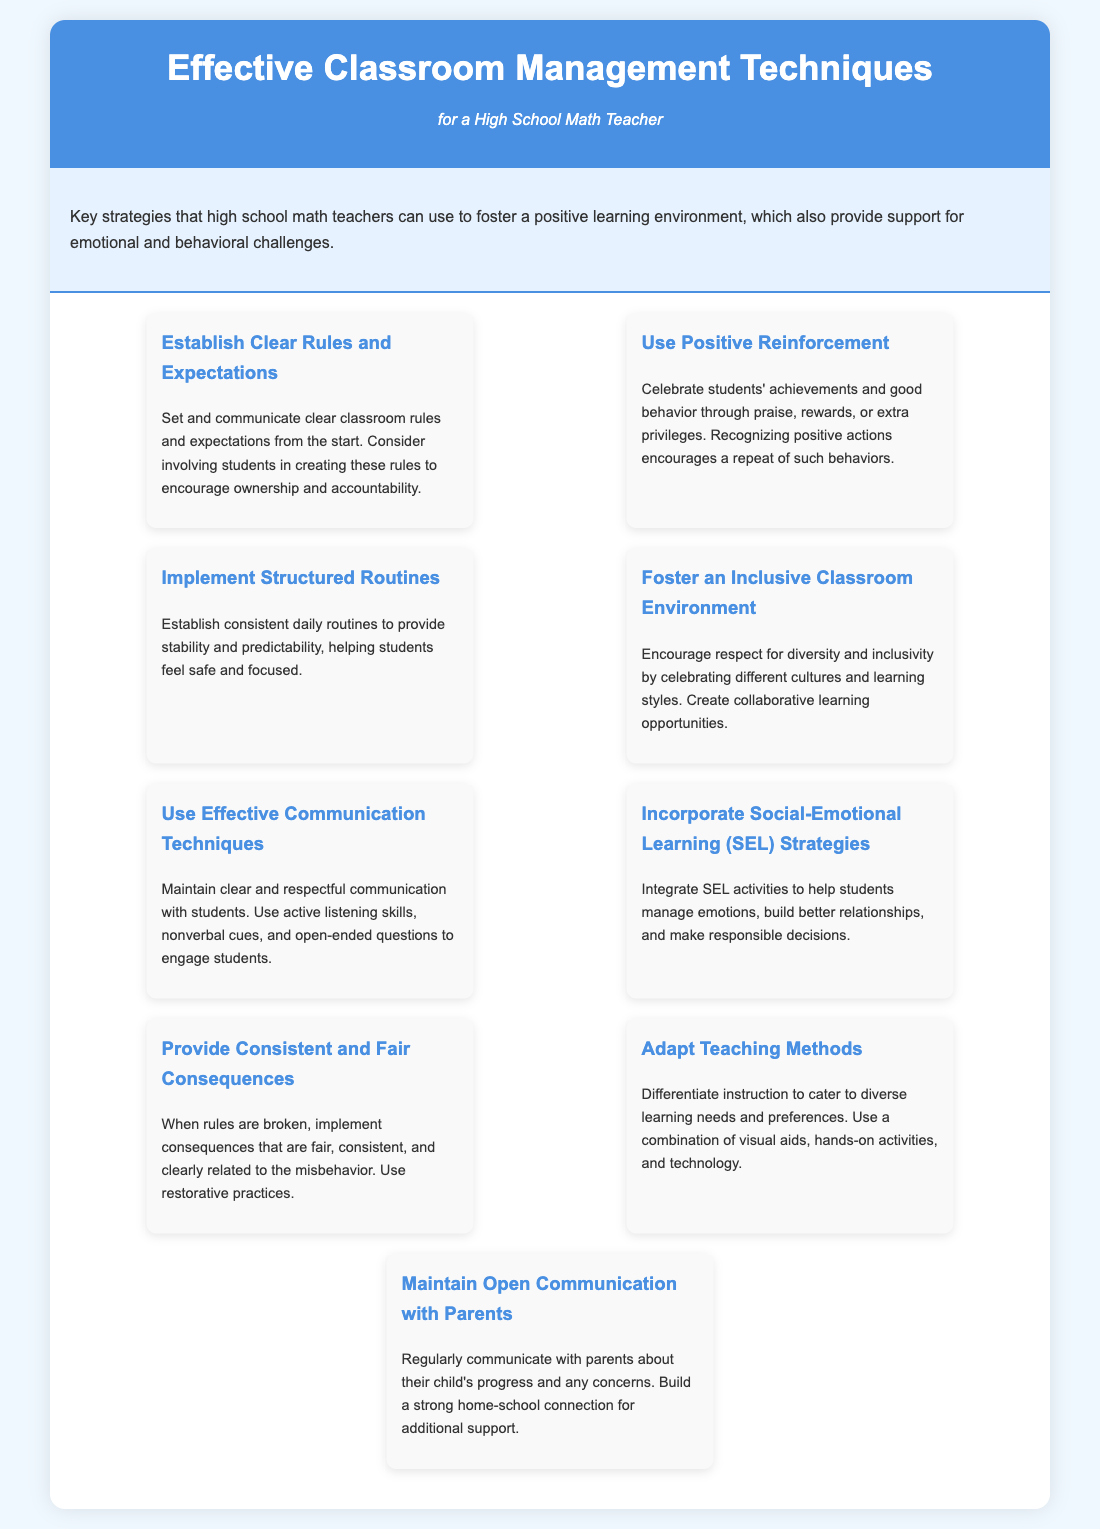What is the title of the infographic? The title is the main heading at the top of the document, summarizing its content.
Answer: Effective Classroom Management Techniques How many techniques are listed? The document contains a specific number of distinct techniques for classroom management, detailed in the infographic.
Answer: Nine What is one technique for creating inclusivity? This question asks for a specific technique mentioned in the document that focuses on inclusivity in the classroom.
Answer: Foster an Inclusive Classroom Environment What strategy should be used for consistent behavior? This question focuses on a specific technique aimed at maintaining consistent behavior among students.
Answer: Provide Consistent and Fair Consequences What type of reinforcement is suggested in the document? This question asks about the approach taken to encourage positive behavior within the classroom setting as mentioned in the document.
Answer: Positive Reinforcement Which technique helps manage emotions? This question inquires about the technique explicitly designed to assist students in emotional regulation, based on the content presented.
Answer: Incorporate Social-Emotional Learning (SEL) Strategies What is the suggested communication method with parents? This question seeks to find one recommended way to maintain dialogue with parents, highlighted in the document.
Answer: Maintain Open Communication with Parents What does the document suggest about teaching methods? This question focuses on a recommendation regarding the flexibility and adaptation of teaching practices according to student needs.
Answer: Adapt Teaching Methods What aspect of classroom rules does the document emphasize? This question asks about a specific focus related to rules and expectations in the classroom management techniques provided.
Answer: Establish Clear Rules and Expectations 